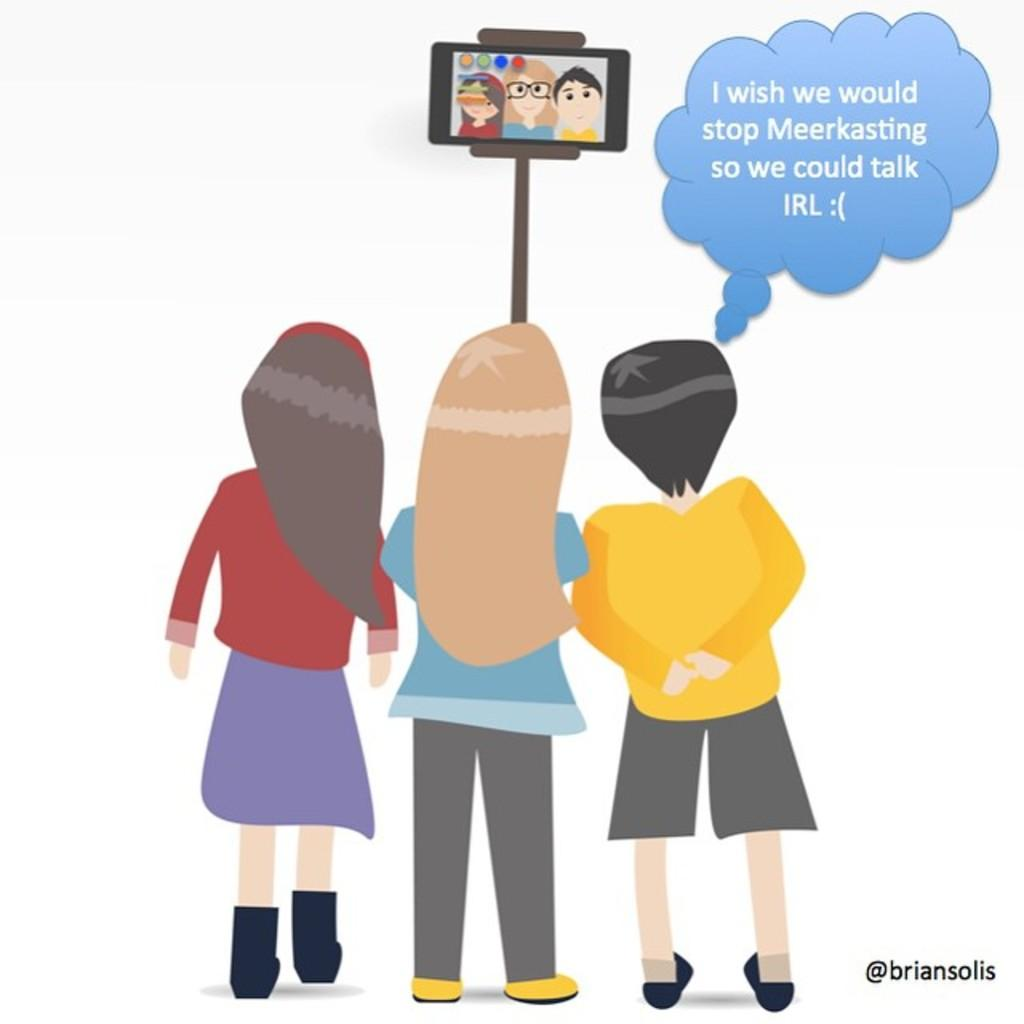What type of image is this? The image appears to be animated. How many people are in the image? There are three persons in the image. What are the people holding in the image? Each person is holding a phone. How are the phones connected in the image? The phones are connected to a selfie stick. What can be seen to the right of the image? There is text visible to the right of the image. What is the cause of death for the person in the image? There is no indication of death or any person in the image; it features three animated characters holding phones connected to a selfie stick. 